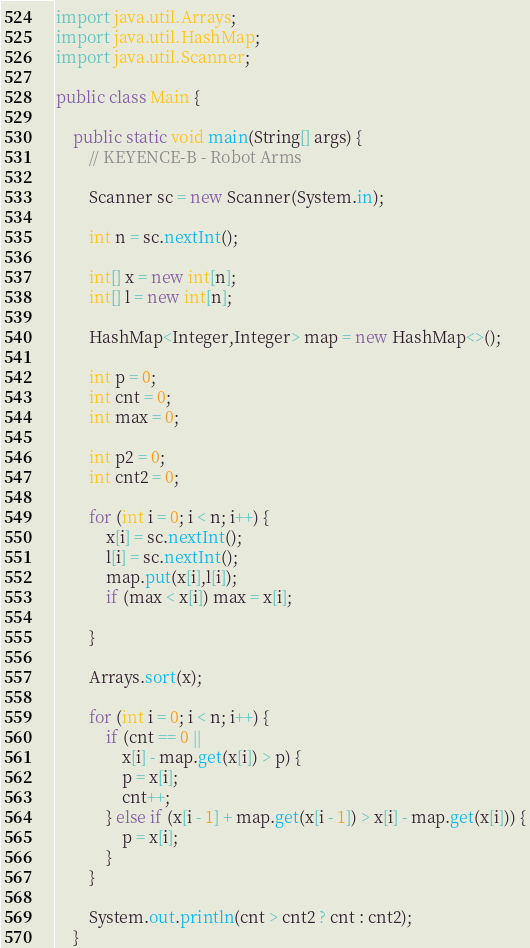<code> <loc_0><loc_0><loc_500><loc_500><_Java_>import java.util.Arrays;
import java.util.HashMap;
import java.util.Scanner;

public class Main {

    public static void main(String[] args) {
        // KEYENCE-B - Robot Arms

        Scanner sc = new Scanner(System.in);

        int n = sc.nextInt();

        int[] x = new int[n];
        int[] l = new int[n];

        HashMap<Integer,Integer> map = new HashMap<>();

        int p = 0;
        int cnt = 0;
        int max = 0;

        int p2 = 0;
        int cnt2 = 0;

        for (int i = 0; i < n; i++) {
            x[i] = sc.nextInt();
            l[i] = sc.nextInt();
            map.put(x[i],l[i]);
            if (max < x[i]) max = x[i];

        }

        Arrays.sort(x);

        for (int i = 0; i < n; i++) {
            if (cnt == 0 ||
                x[i] - map.get(x[i]) > p) {
                p = x[i];
                cnt++;
            } else if (x[i - 1] + map.get(x[i - 1]) > x[i] - map.get(x[i])) {
                p = x[i];
            }
        }

        System.out.println(cnt > cnt2 ? cnt : cnt2);
    }</code> 